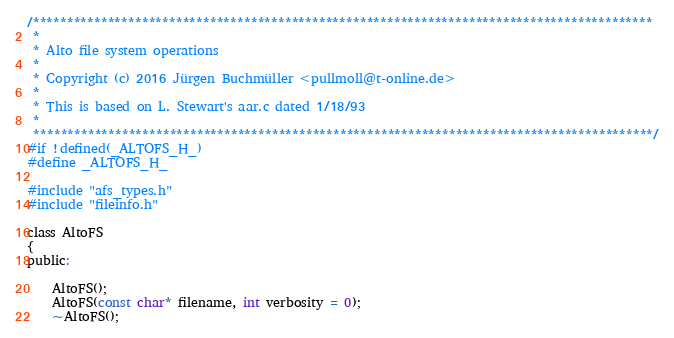<code> <loc_0><loc_0><loc_500><loc_500><_C_>/*******************************************************************************************
 *
 * Alto file system operations
 *
 * Copyright (c) 2016 Jürgen Buchmüller <pullmoll@t-online.de>
 *
 * This is based on L. Stewart's aar.c dated 1/18/93
 *
 *******************************************************************************************/
#if !defined(_ALTOFS_H_)
#define _ALTOFS_H_

#include "afs_types.h"
#include "fileinfo.h"

class AltoFS
{
public:

    AltoFS();
    AltoFS(const char* filename, int verbosity = 0);
    ~AltoFS();
</code> 